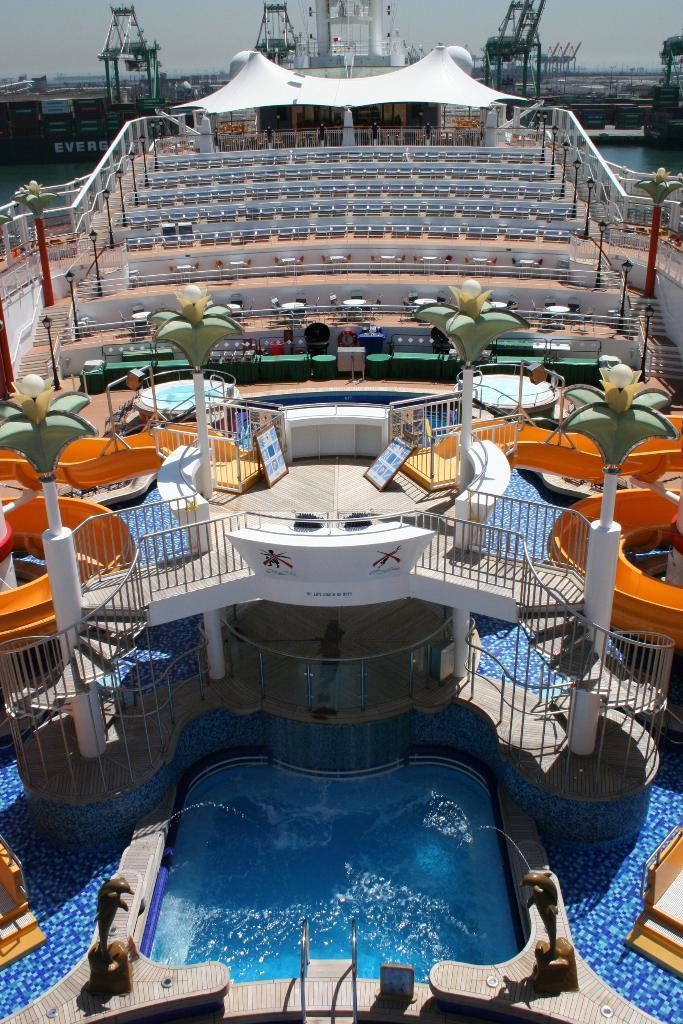What is the primary element visible in the image? There is water in the image. What type of structure can be seen in the image? There is a fence in the image. What material is used to create the structure in the image? There are boards in the image. What can be used for sitting or resting in the image? There are seats in the image. What part of the natural environment is visible in the background of the image? The sky is visible in the background of the image. What type of connection is being made between the water and the fence in the image? There is no direct connection between the water and the fence in the image; they are separate elements. How does the rainstorm affect the water and fence in the image? There is no rainstorm present in the image, so its effect cannot be determined. 